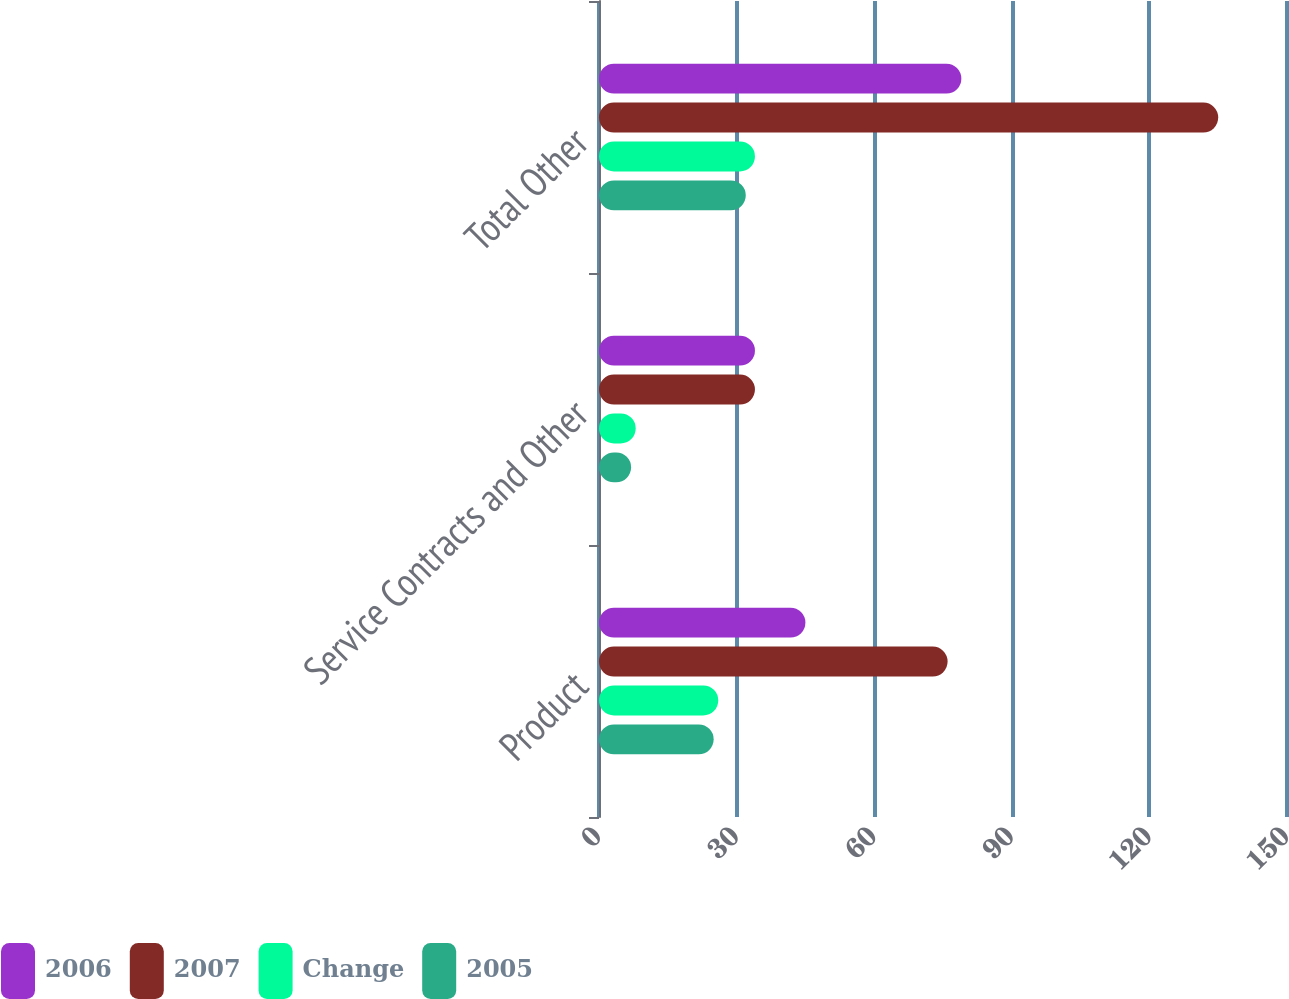Convert chart. <chart><loc_0><loc_0><loc_500><loc_500><stacked_bar_chart><ecel><fcel>Product<fcel>Service Contracts and Other<fcel>Total Other<nl><fcel>2006<fcel>45<fcel>34<fcel>79<nl><fcel>2007<fcel>76<fcel>34<fcel>135<nl><fcel>Change<fcel>26<fcel>8<fcel>34<nl><fcel>2005<fcel>25<fcel>7<fcel>32<nl></chart> 